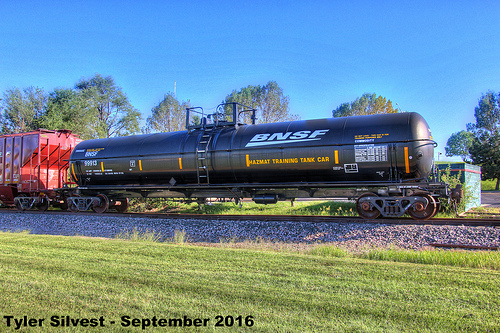<image>
Is the tree behind the train? Yes. From this viewpoint, the tree is positioned behind the train, with the train partially or fully occluding the tree. 